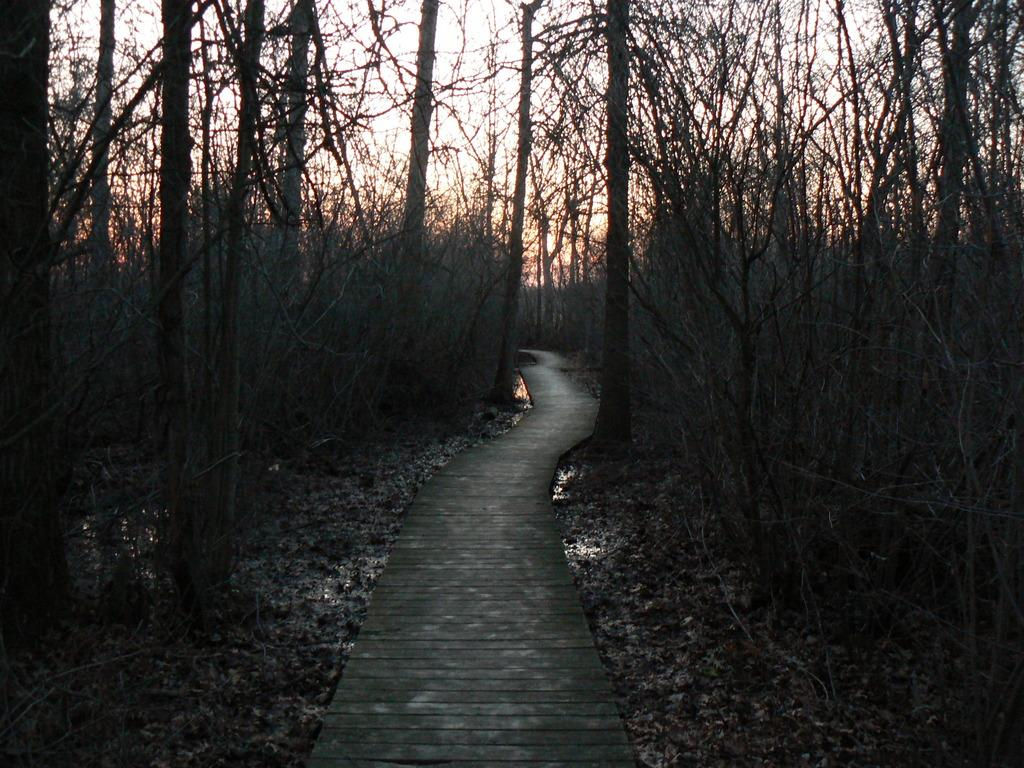What type of path is visible in the image? There is a wooden path in the image. Where is the wooden path located? The wooden path is in a forest. What can be seen in the image besides the wooden path? There are trees in the image. What is visible in the background of the image? The sky is visible in the background of the image, partially obscured by trees. Are there any giants walking along the wooden path in the image? No, there are no giants present in the image. What grade is the wooden path in the image? The wooden path is not associated with a grade; it is simply a path in a forest. 